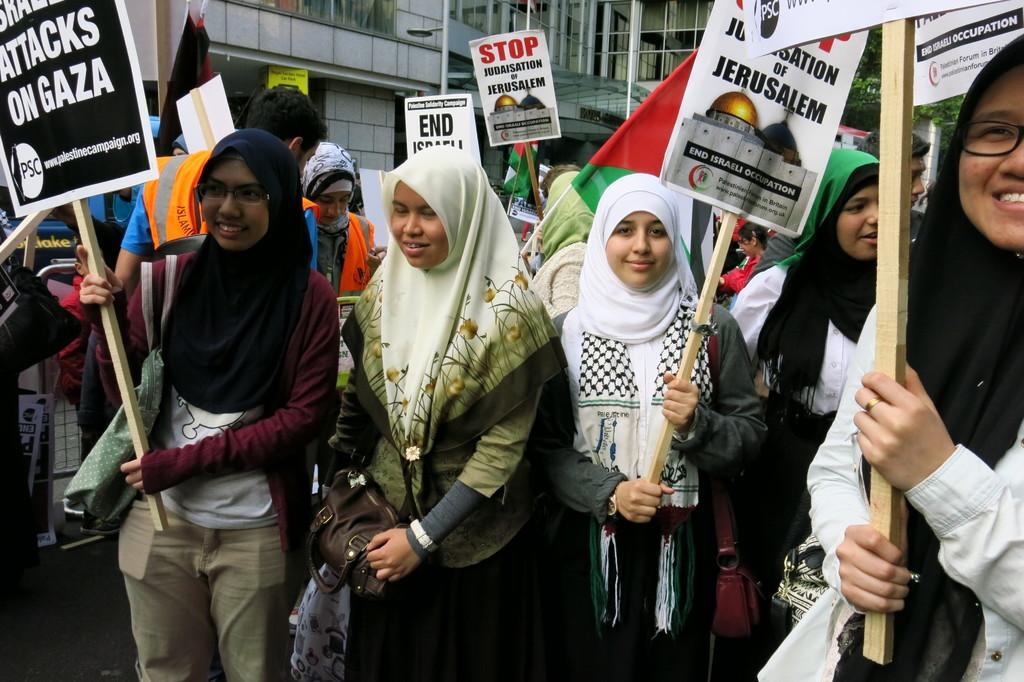What are the women in the image doing? The women in the image are standing on the road. What are the women holding in their hands? The women are holding placards in their hands. What can be seen in the background of the image? There are buildings in the background of the image. What statement does the dad make in the image? There is no dad present in the image, so it is not possible to answer that question. 